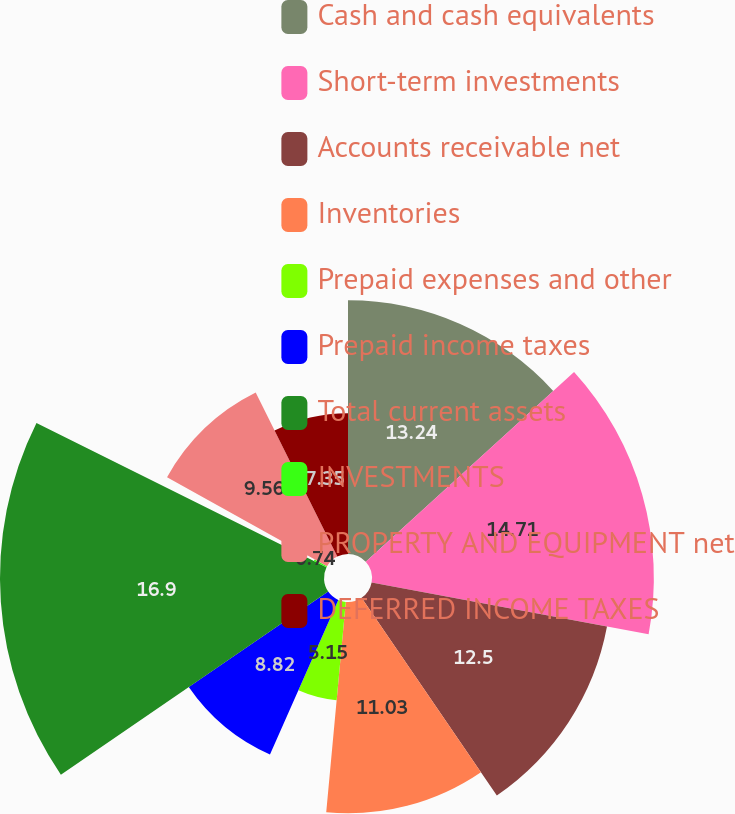Convert chart. <chart><loc_0><loc_0><loc_500><loc_500><pie_chart><fcel>Cash and cash equivalents<fcel>Short-term investments<fcel>Accounts receivable net<fcel>Inventories<fcel>Prepaid expenses and other<fcel>Prepaid income taxes<fcel>Total current assets<fcel>INVESTMENTS<fcel>PROPERTY AND EQUIPMENT net<fcel>DEFERRED INCOME TAXES<nl><fcel>13.24%<fcel>14.71%<fcel>12.5%<fcel>11.03%<fcel>5.15%<fcel>8.82%<fcel>16.91%<fcel>0.74%<fcel>9.56%<fcel>7.35%<nl></chart> 